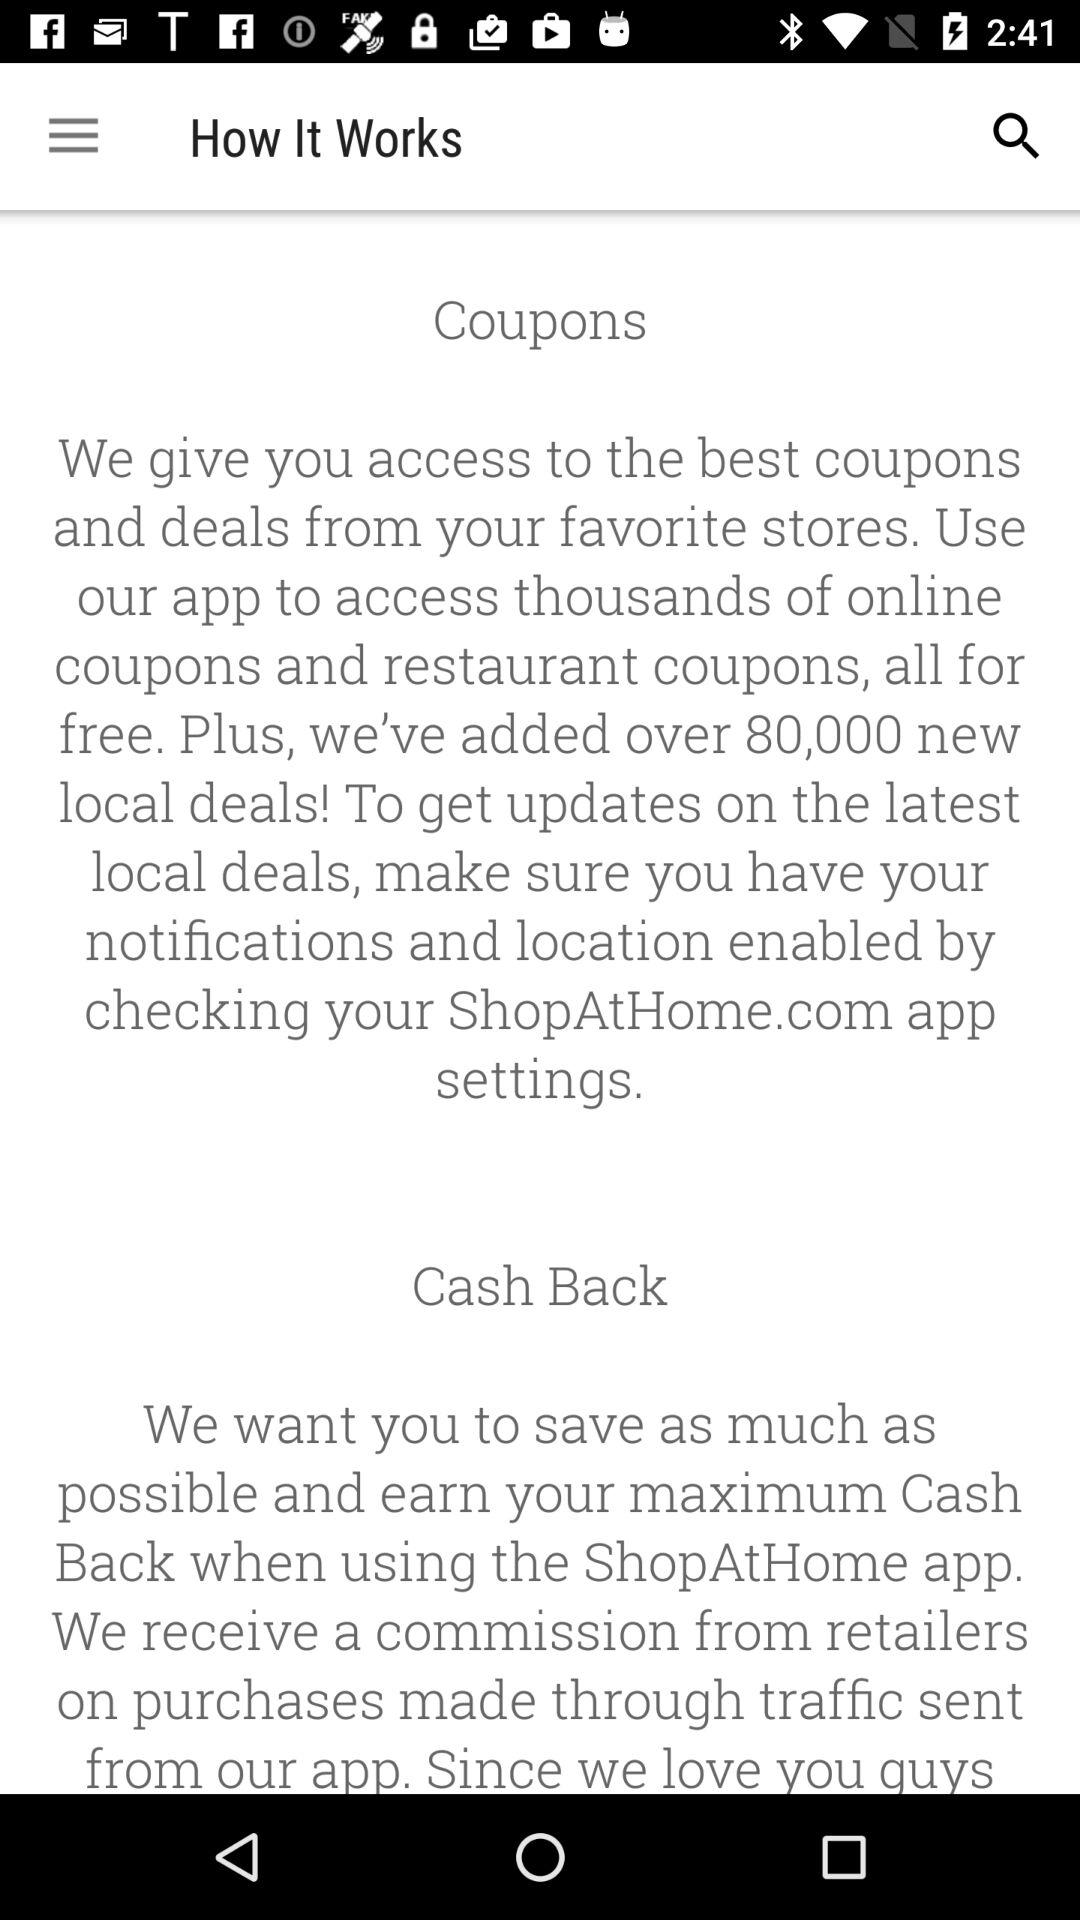How many new local deals in total have been added? There have been over 80,000 new local deals added. 